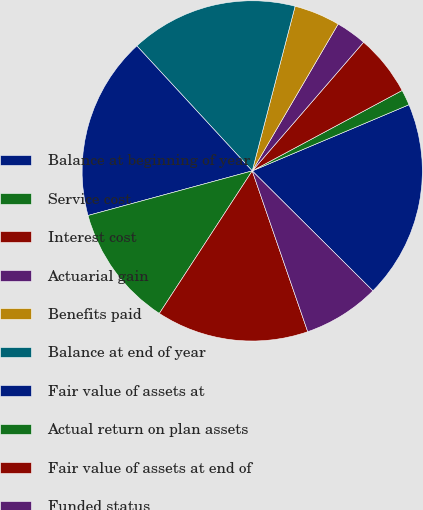Convert chart. <chart><loc_0><loc_0><loc_500><loc_500><pie_chart><fcel>Balance at beginning of year<fcel>Service cost<fcel>Interest cost<fcel>Actuarial gain<fcel>Benefits paid<fcel>Balance at end of year<fcel>Fair value of assets at<fcel>Actual return on plan assets<fcel>Fair value of assets at end of<fcel>Funded status<nl><fcel>18.81%<fcel>1.48%<fcel>5.81%<fcel>2.93%<fcel>4.37%<fcel>15.92%<fcel>17.36%<fcel>11.59%<fcel>14.48%<fcel>7.26%<nl></chart> 